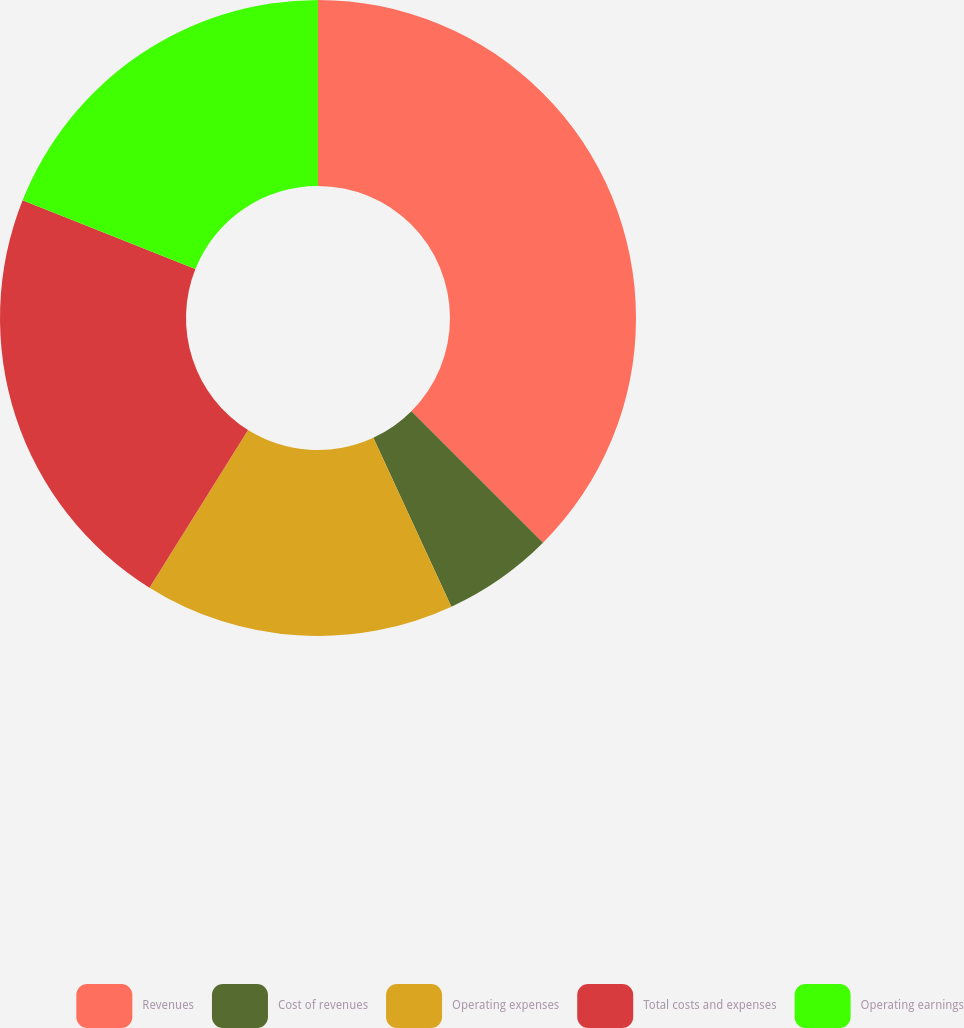Convert chart to OTSL. <chart><loc_0><loc_0><loc_500><loc_500><pie_chart><fcel>Revenues<fcel>Cost of revenues<fcel>Operating expenses<fcel>Total costs and expenses<fcel>Operating earnings<nl><fcel>37.49%<fcel>5.62%<fcel>15.78%<fcel>22.15%<fcel>18.96%<nl></chart> 